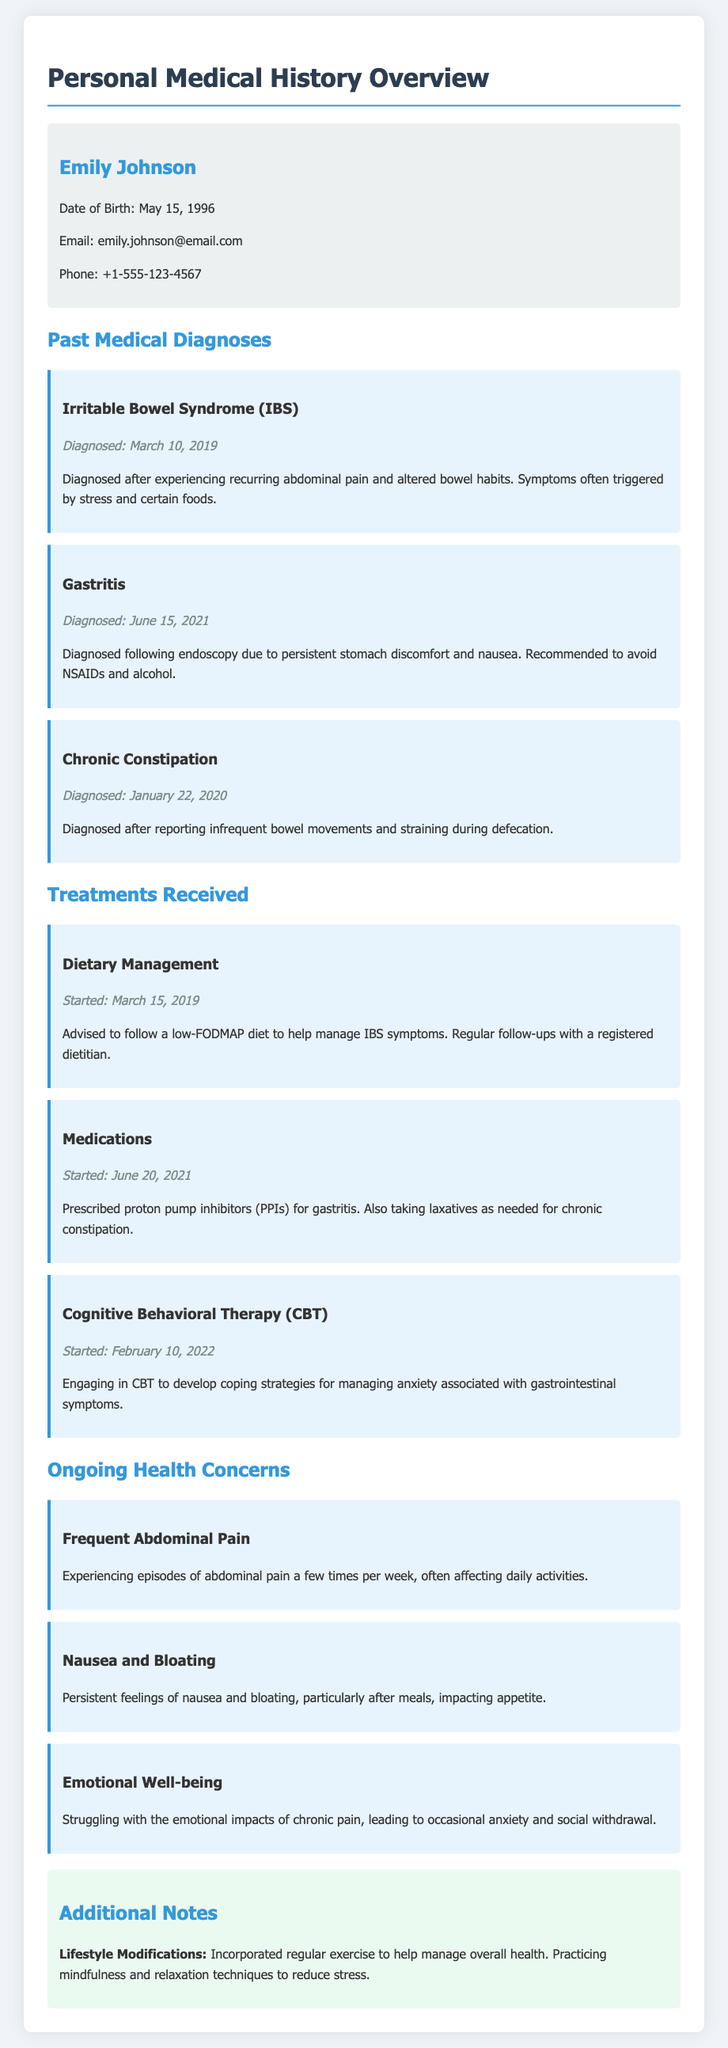What is Emily Johnson's date of birth? The date of birth is specified in the personal information section of the document.
Answer: May 15, 1996 When was Emily diagnosed with Irritable Bowel Syndrome? The date of diagnosis for each condition is listed under past medical diagnoses.
Answer: March 10, 2019 What dietary approach is Emily using to manage her IBS symptoms? The document mentions a specific dietary management strategy employed for IBS.
Answer: Low-FODMAP diet What medication is Emily prescribed for gastritis? The treatments section specifies the medication prescribed for her gastritis condition.
Answer: Proton pump inhibitors How often does Emily experience abdominal pain? The ongoing health concerns section describes the frequency of her abdominal pain episodes.
Answer: A few times per week What therapy is Emily engaging in for her emotional well-being? The treatments section includes the type of therapy aimed at managing anxiety.
Answer: Cognitive Behavioral Therapy (CBT) What was one of the lifestyle modifications Emily incorporated? The additional notes section describes a change in Emily's lifestyle for health management.
Answer: Regular exercise When was Emily diagnosed with gastritis? The date of diagnosis is outlined in the past medical diagnoses section of the document.
Answer: June 15, 2021 What ongoing health concern impacts Emily's appetite? The ongoing health concerns describe specific symptoms affecting her appetite.
Answer: Nausea and bloating 